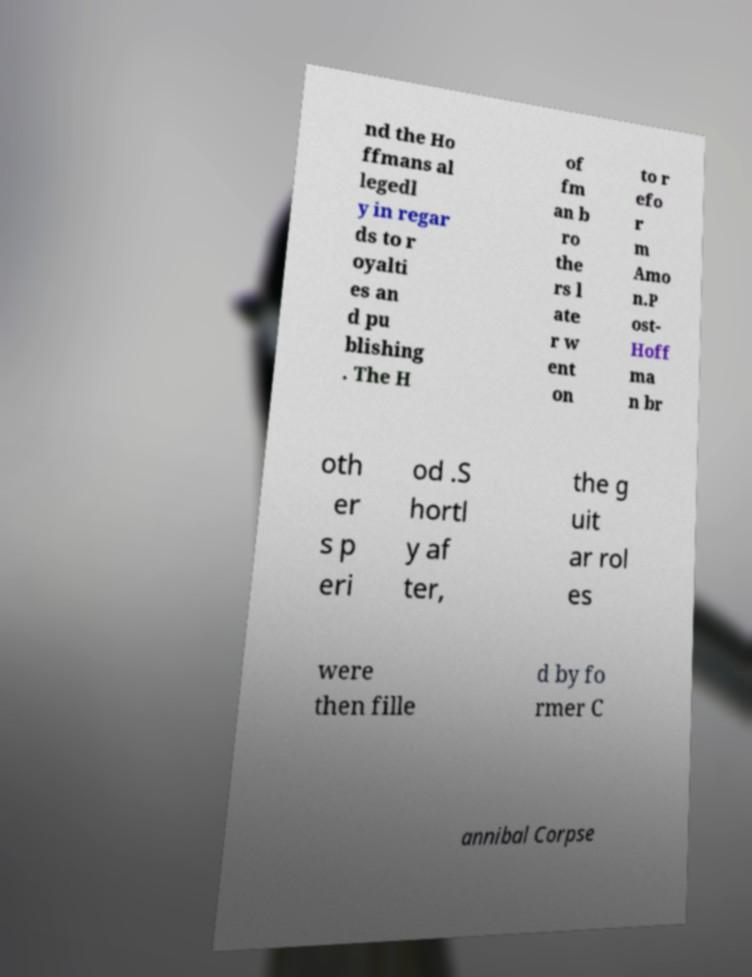There's text embedded in this image that I need extracted. Can you transcribe it verbatim? nd the Ho ffmans al legedl y in regar ds to r oyalti es an d pu blishing . The H of fm an b ro the rs l ate r w ent on to r efo r m Amo n.P ost- Hoff ma n br oth er s p eri od .S hortl y af ter, the g uit ar rol es were then fille d by fo rmer C annibal Corpse 